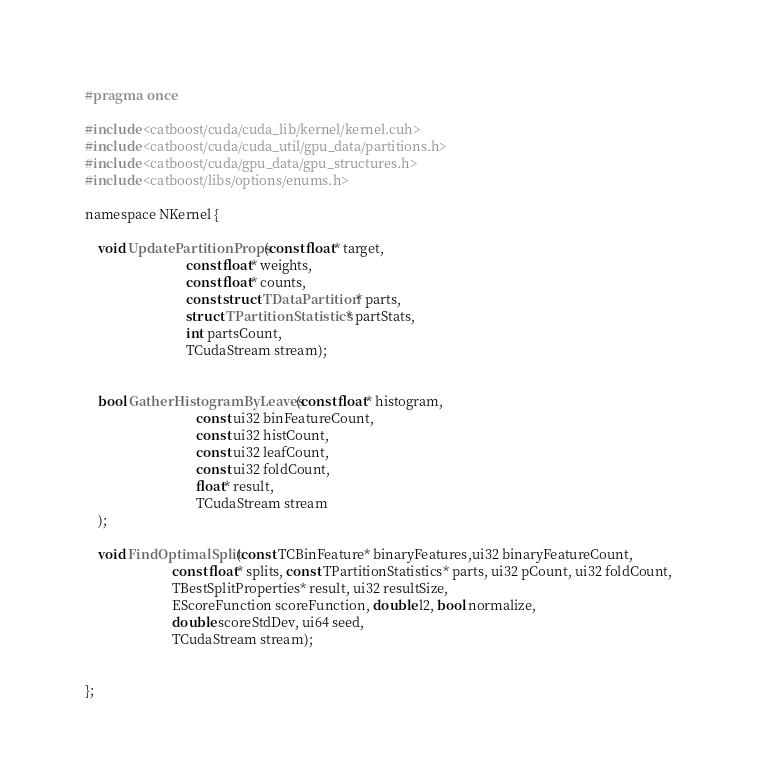<code> <loc_0><loc_0><loc_500><loc_500><_Cuda_>#pragma once

#include <catboost/cuda/cuda_lib/kernel/kernel.cuh>
#include <catboost/cuda/cuda_util/gpu_data/partitions.h>
#include <catboost/cuda/gpu_data/gpu_structures.h>
#include <catboost/libs/options/enums.h>

namespace NKernel {

    void UpdatePartitionProps(const float* target,
                              const float* weights,
                              const float* counts,
                              const struct TDataPartition* parts,
                              struct TPartitionStatistics* partStats,
                              int partsCount,
                              TCudaStream stream);


    bool GatherHistogramByLeaves(const float* histogram,
                                 const ui32 binFeatureCount,
                                 const ui32 histCount,
                                 const ui32 leafCount,
                                 const ui32 foldCount,
                                 float* result,
                                 TCudaStream stream
    );

    void FindOptimalSplit(const TCBinFeature* binaryFeatures,ui32 binaryFeatureCount,
                          const float* splits, const TPartitionStatistics* parts, ui32 pCount, ui32 foldCount,
                          TBestSplitProperties* result, ui32 resultSize,
                          EScoreFunction scoreFunction, double l2, bool normalize,
                          double scoreStdDev, ui64 seed,
                          TCudaStream stream);


};
</code> 